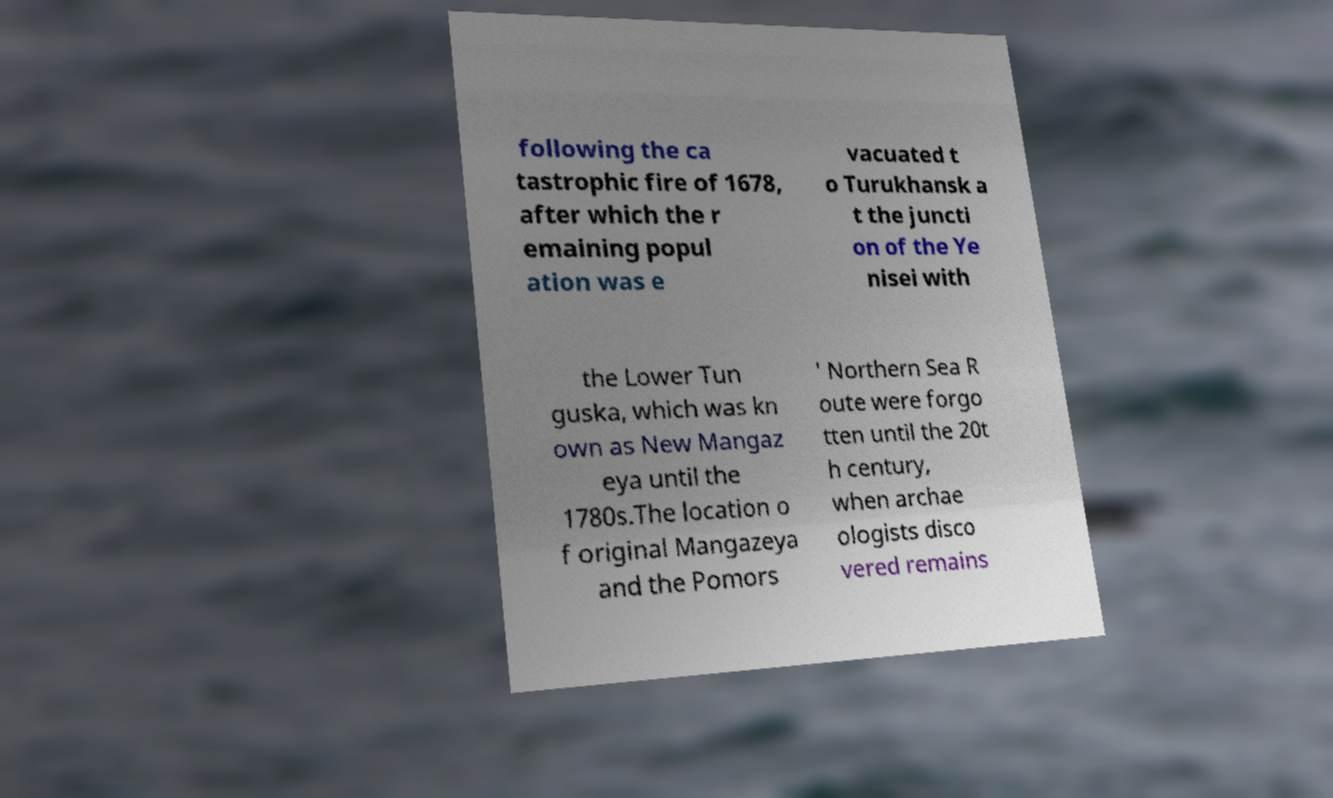Could you assist in decoding the text presented in this image and type it out clearly? following the ca tastrophic fire of 1678, after which the r emaining popul ation was e vacuated t o Turukhansk a t the juncti on of the Ye nisei with the Lower Tun guska, which was kn own as New Mangaz eya until the 1780s.The location o f original Mangazeya and the Pomors ' Northern Sea R oute were forgo tten until the 20t h century, when archae ologists disco vered remains 